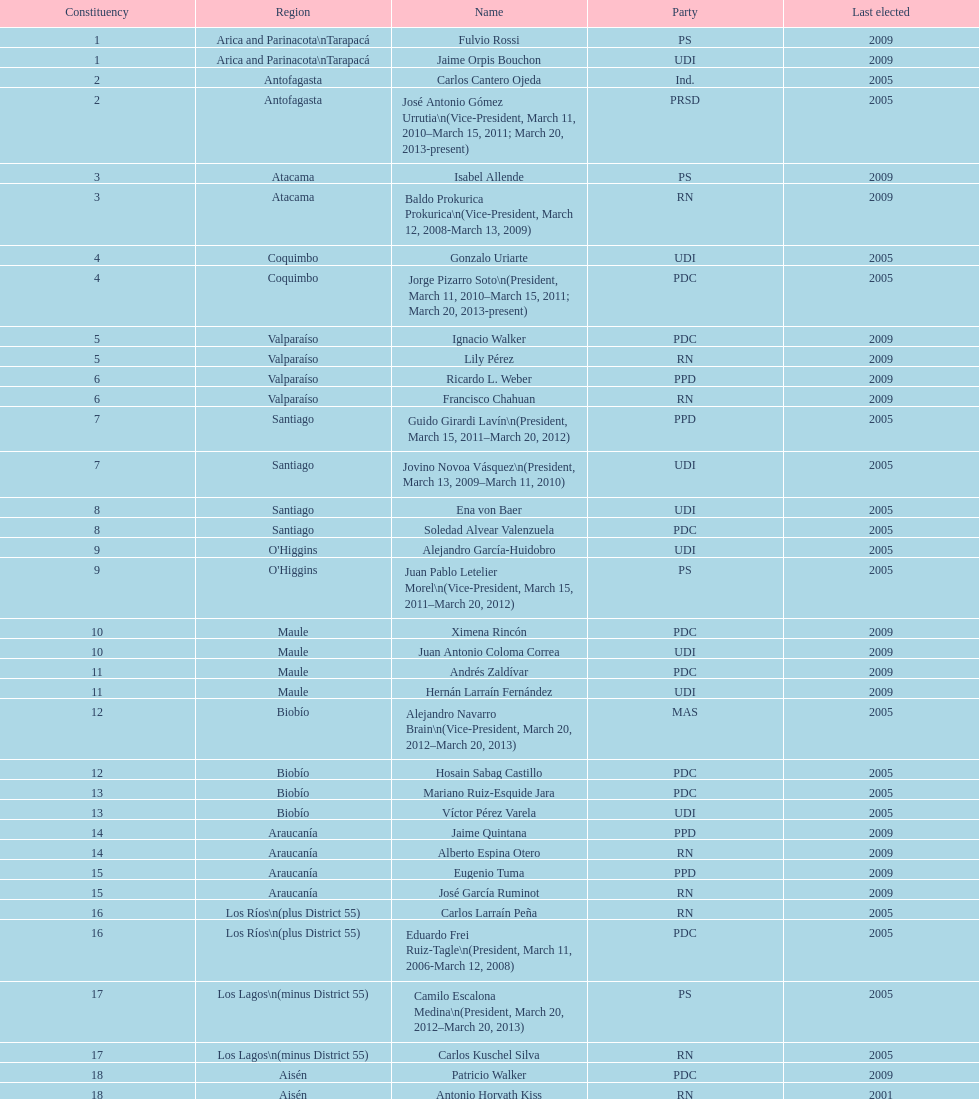For how long did baldo prokurica serve as vice-president? 1 year. 